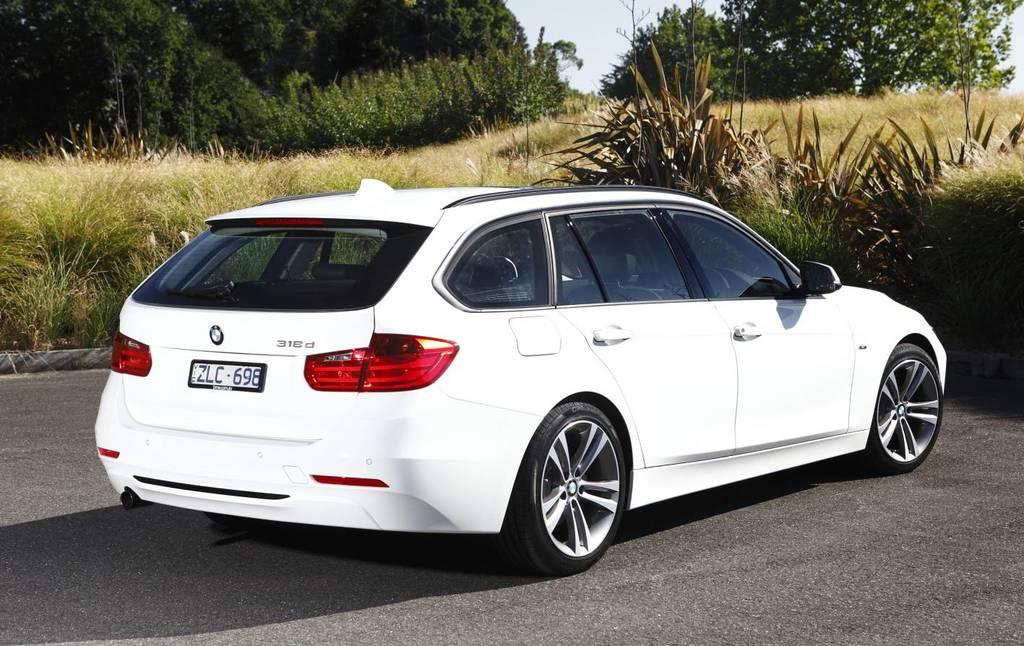<image>
Provide a brief description of the given image. A white BMW 318d station wagon parked in front of a field. 